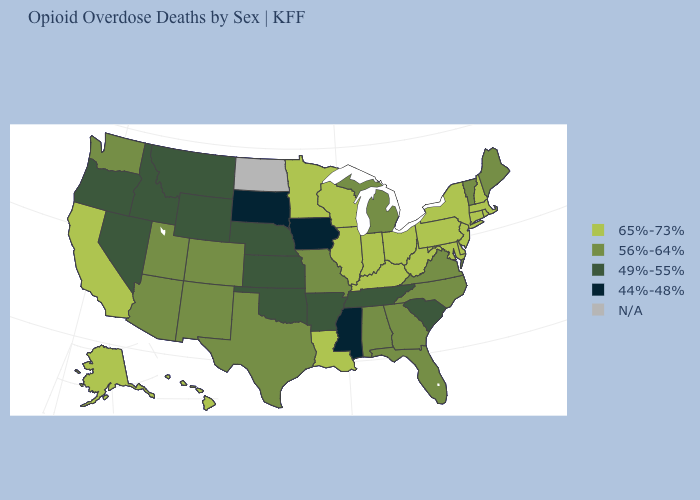What is the highest value in the USA?
Concise answer only. 65%-73%. Which states have the highest value in the USA?
Give a very brief answer. Alaska, California, Connecticut, Delaware, Hawaii, Illinois, Indiana, Kentucky, Louisiana, Maryland, Massachusetts, Minnesota, New Hampshire, New Jersey, New York, Ohio, Pennsylvania, Rhode Island, West Virginia, Wisconsin. What is the value of Georgia?
Quick response, please. 56%-64%. Name the states that have a value in the range 44%-48%?
Short answer required. Iowa, Mississippi, South Dakota. Name the states that have a value in the range 65%-73%?
Concise answer only. Alaska, California, Connecticut, Delaware, Hawaii, Illinois, Indiana, Kentucky, Louisiana, Maryland, Massachusetts, Minnesota, New Hampshire, New Jersey, New York, Ohio, Pennsylvania, Rhode Island, West Virginia, Wisconsin. Among the states that border Florida , which have the lowest value?
Be succinct. Alabama, Georgia. What is the lowest value in states that border South Carolina?
Concise answer only. 56%-64%. What is the lowest value in the South?
Short answer required. 44%-48%. Among the states that border Vermont , which have the lowest value?
Give a very brief answer. Massachusetts, New Hampshire, New York. Name the states that have a value in the range 44%-48%?
Concise answer only. Iowa, Mississippi, South Dakota. Name the states that have a value in the range 56%-64%?
Keep it brief. Alabama, Arizona, Colorado, Florida, Georgia, Maine, Michigan, Missouri, New Mexico, North Carolina, Texas, Utah, Vermont, Virginia, Washington. Which states hav the highest value in the MidWest?
Short answer required. Illinois, Indiana, Minnesota, Ohio, Wisconsin. 